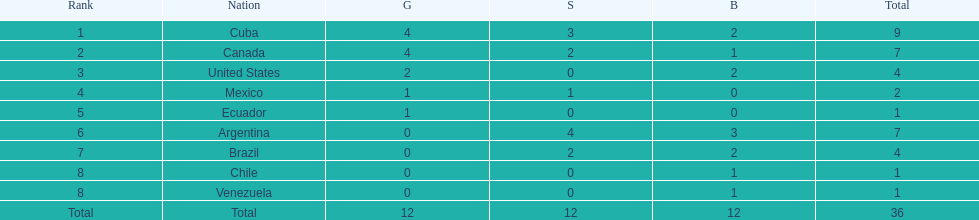Which nations participated? Cuba, Canada, United States, Mexico, Ecuador, Argentina, Brazil, Chile, Venezuela. Which nations won gold? Cuba, Canada, United States, Mexico, Ecuador. Which nations did not win silver? United States, Ecuador, Chile, Venezuela. Out of those countries previously listed, which nation won gold? United States. 